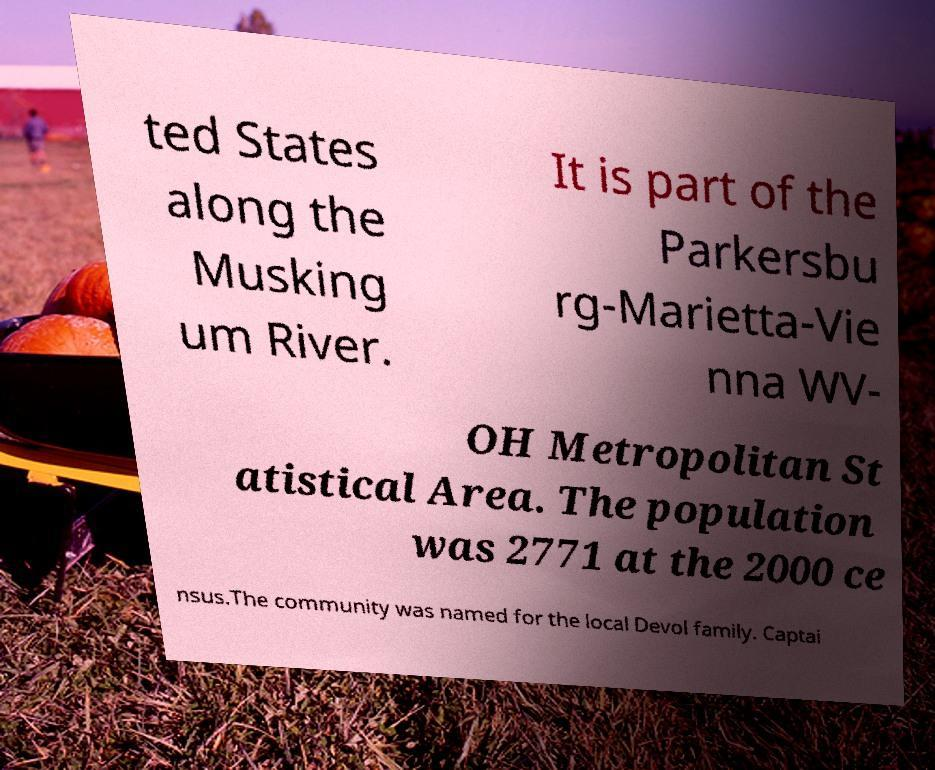I need the written content from this picture converted into text. Can you do that? ted States along the Musking um River. It is part of the Parkersbu rg-Marietta-Vie nna WV- OH Metropolitan St atistical Area. The population was 2771 at the 2000 ce nsus.The community was named for the local Devol family. Captai 